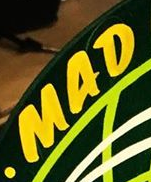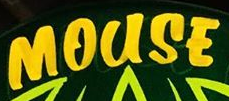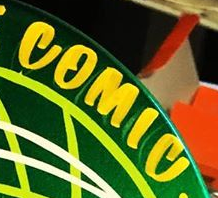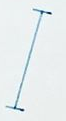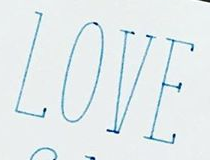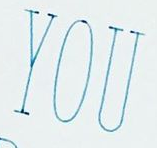Read the text content from these images in order, separated by a semicolon. MAD; MOUSE; COMIC; I; LOVE; YOU 